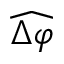<formula> <loc_0><loc_0><loc_500><loc_500>\widehat { \Delta \varphi }</formula> 